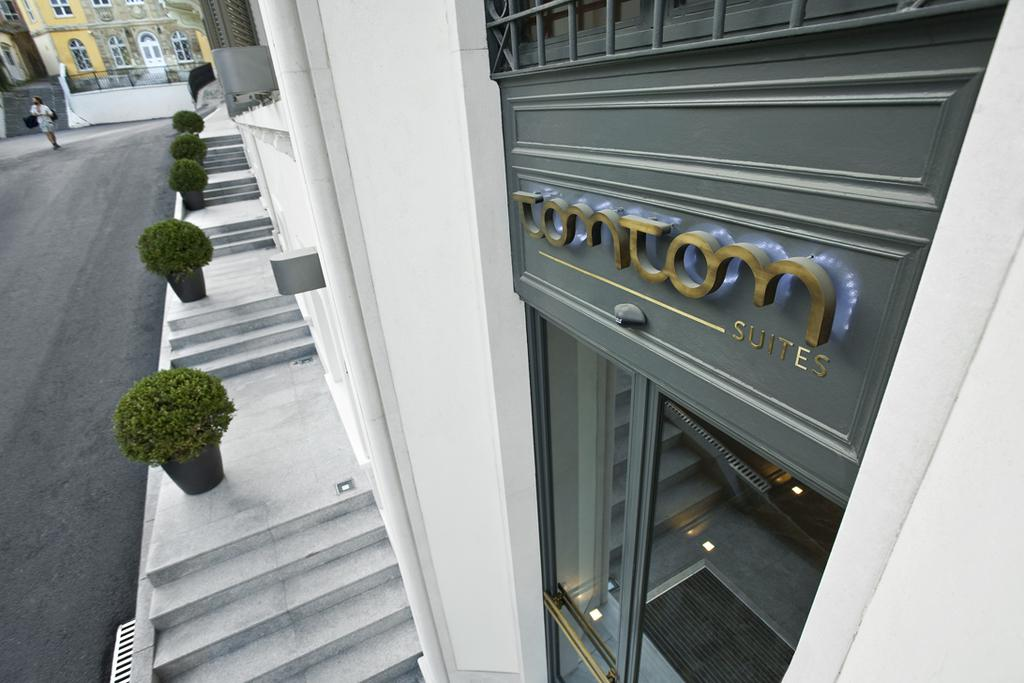<image>
Offer a succinct explanation of the picture presented. A SIDEWALK VIEW OF THE TOMTOM SUITES WITH POTTED PLANTERS 